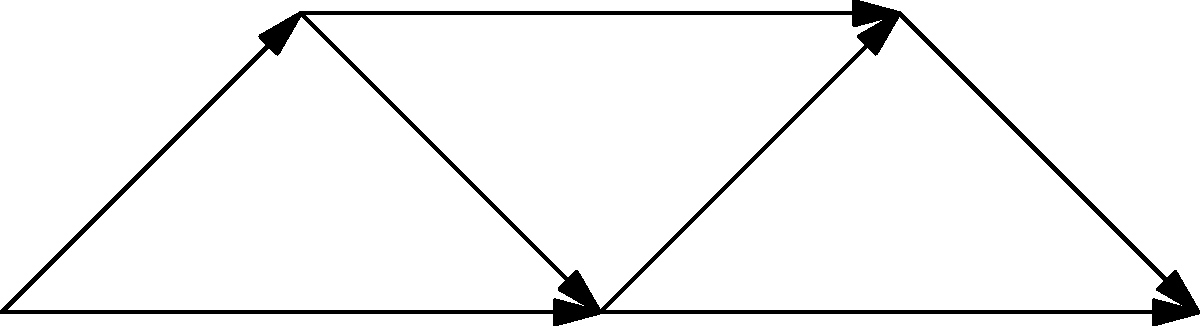Consider a network of 5 nodes representing social media platforms, as shown in the diagram. The spread of disinformation across this network can be modeled using the following system of differential equations:

$$\begin{aligned}
\frac{dN_1}{dt} &= \alpha N_1(1-N_1) - \beta N_1N_2 - \gamma N_1N_3 \\
\frac{dN_2}{dt} &= \alpha N_2(1-N_2) - \beta N_2N_3 - \gamma N_2N_4 \\
\frac{dN_3}{dt} &= \alpha N_3(1-N_3) - \beta N_3N_4 - \gamma N_3N_5 \\
\frac{dN_4}{dt} &= \alpha N_4(1-N_4) - \beta N_4N_5 \\
\frac{dN_5}{dt} &= \alpha N_5(1-N_5)
\end{aligned}$$

Where $N_i$ represents the proportion of users exposed to disinformation on platform $i$, $\alpha$ is the rate of disinformation spread within a platform, $\beta$ is the rate of spread between directly connected platforms, and $\gamma$ is the rate of spread between indirectly connected platforms.

Given that $\alpha = 0.3$, $\beta = 0.2$, and $\gamma = 0.1$, calculate the rate of change of disinformation exposure on platform 3 ($\frac{dN_3}{dt}$) when $N_1 = 0.4$, $N_2 = 0.5$, $N_3 = 0.3$, $N_4 = 0.2$, and $N_5 = 0.1$. To solve this problem, we need to follow these steps:

1) Identify the equation for $\frac{dN_3}{dt}$ from the system of differential equations:

   $$\frac{dN_3}{dt} = \alpha N_3(1-N_3) - \beta N_3N_4 - \gamma N_3N_5$$

2) Substitute the given values:
   $\alpha = 0.3$, $\beta = 0.2$, $\gamma = 0.1$
   $N_3 = 0.3$, $N_4 = 0.2$, $N_5 = 0.1$

3) Calculate each term:
   
   First term: $\alpha N_3(1-N_3) = 0.3 \cdot 0.3 \cdot (1-0.3) = 0.063$
   
   Second term: $\beta N_3N_4 = 0.2 \cdot 0.3 \cdot 0.2 = 0.012$
   
   Third term: $\gamma N_3N_5 = 0.1 \cdot 0.3 \cdot 0.1 = 0.003$

4) Combine the terms:

   $$\frac{dN_3}{dt} = 0.063 - 0.012 - 0.003 = 0.048$$

Therefore, the rate of change of disinformation exposure on platform 3 is 0.048 or 4.8% per unit time.
Answer: 0.048 